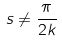<formula> <loc_0><loc_0><loc_500><loc_500>s \ne \frac { \pi } { 2 k }</formula> 